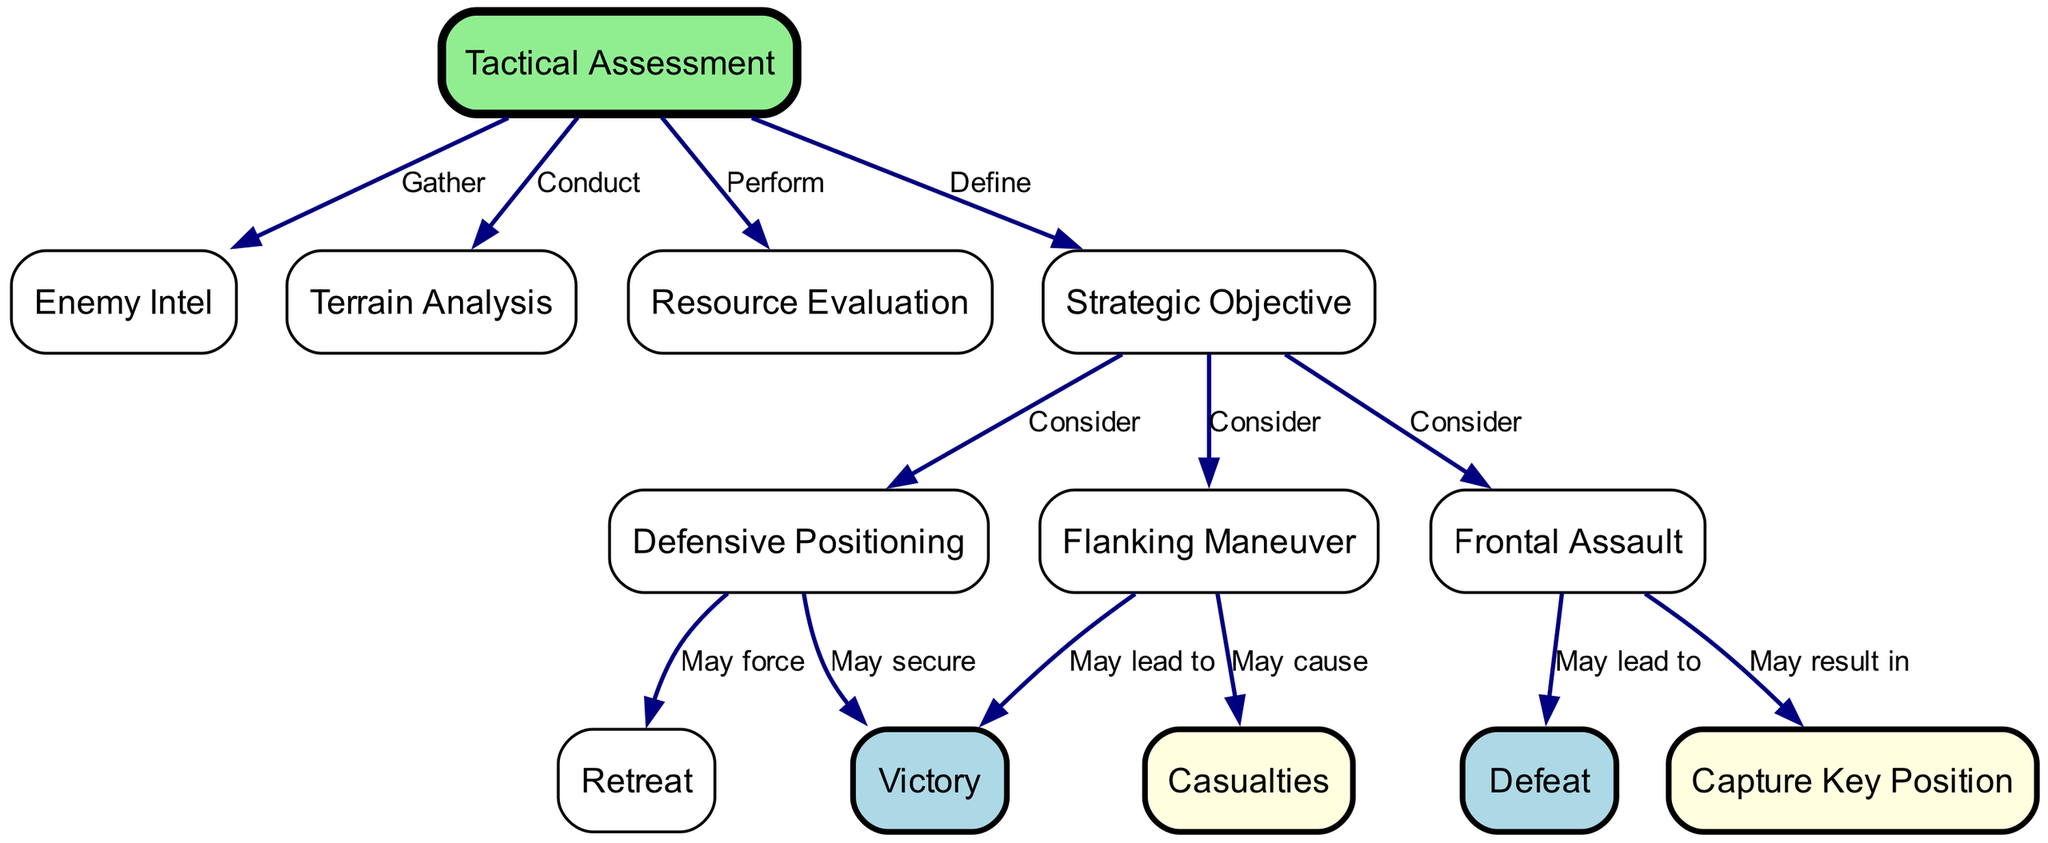What is the starting point of the decision-making process? The diagram shows "Tactical Assessment" as the first node, indicating it is where the decision-making process begins, leading to various evaluations and considerations.
Answer: Tactical Assessment How many nodes are present in the diagram? By counting the distinct nodes listed in the data, I find there are 12 nodes total, representing different stages or elements in the tactical decision-making process.
Answer: 12 Which maneuver may lead to victory? The directed edge from "Flanking Maneuver" to "Victory" indicates that this particular choice has the potential to result in a successful outcome.
Answer: Flanking Maneuver What may cause casualties? The connection from "Flanking Maneuver" to "Casualties" shows that executing this maneuver might result in losses among soldiers during the battle.
Answer: Flanking Maneuver What is one possible outcome of a frontal assault? The diagram presents the result of a frontal assault as leading to either the capturing of a key position or potential defeat, demonstrating the risks associated with this strategy.
Answer: Capture Key Position What are the three considerations once the strategic objective is defined? The diagram outlines three subsequent paths: "Flanking Maneuver," "Frontal Assault," and "Defensive Positioning," all marked as considerations stemming from the strategic objective.
Answer: Flanking Maneuver, Frontal Assault, Defensive Positioning Which node may force a retreat? The edge from "Defensive Positioning" to "Retreat" indicates that under certain conditions, a well-placed defense may ultimately necessitate falling back from the battle.
Answer: Defensive Positioning What effect does defensive positioning have on victory? The directed edge from "Defensive Positioning" to "Victory" signifies that maintaining a strong defensive stance can secure a successful outcome as part of the tactical strategy.
Answer: May secure What are the consequences of a frontal assault? The options stemming from "Frontal Assault" include both capturing a key position and encountering defeat, indicating the strategic risks present with this approach.
Answer: Capture Key Position, Defeat 